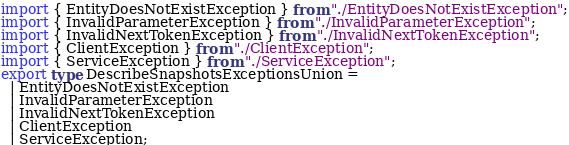Convert code to text. <code><loc_0><loc_0><loc_500><loc_500><_TypeScript_>import { EntityDoesNotExistException } from "./EntityDoesNotExistException";
import { InvalidParameterException } from "./InvalidParameterException";
import { InvalidNextTokenException } from "./InvalidNextTokenException";
import { ClientException } from "./ClientException";
import { ServiceException } from "./ServiceException";
export type DescribeSnapshotsExceptionsUnion =
  | EntityDoesNotExistException
  | InvalidParameterException
  | InvalidNextTokenException
  | ClientException
  | ServiceException;
</code> 